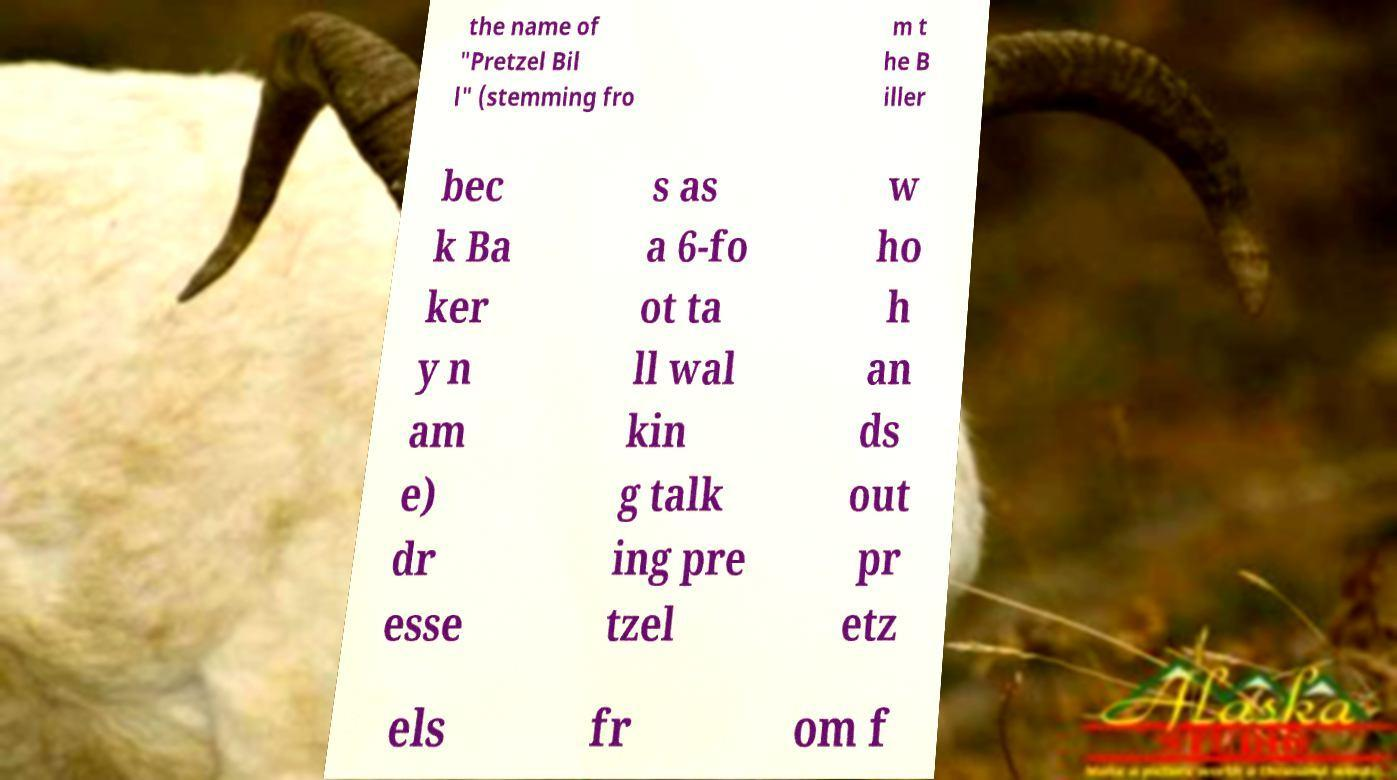What messages or text are displayed in this image? I need them in a readable, typed format. the name of "Pretzel Bil l" (stemming fro m t he B iller bec k Ba ker y n am e) dr esse s as a 6-fo ot ta ll wal kin g talk ing pre tzel w ho h an ds out pr etz els fr om f 